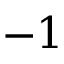Convert formula to latex. <formula><loc_0><loc_0><loc_500><loc_500>- 1</formula> 